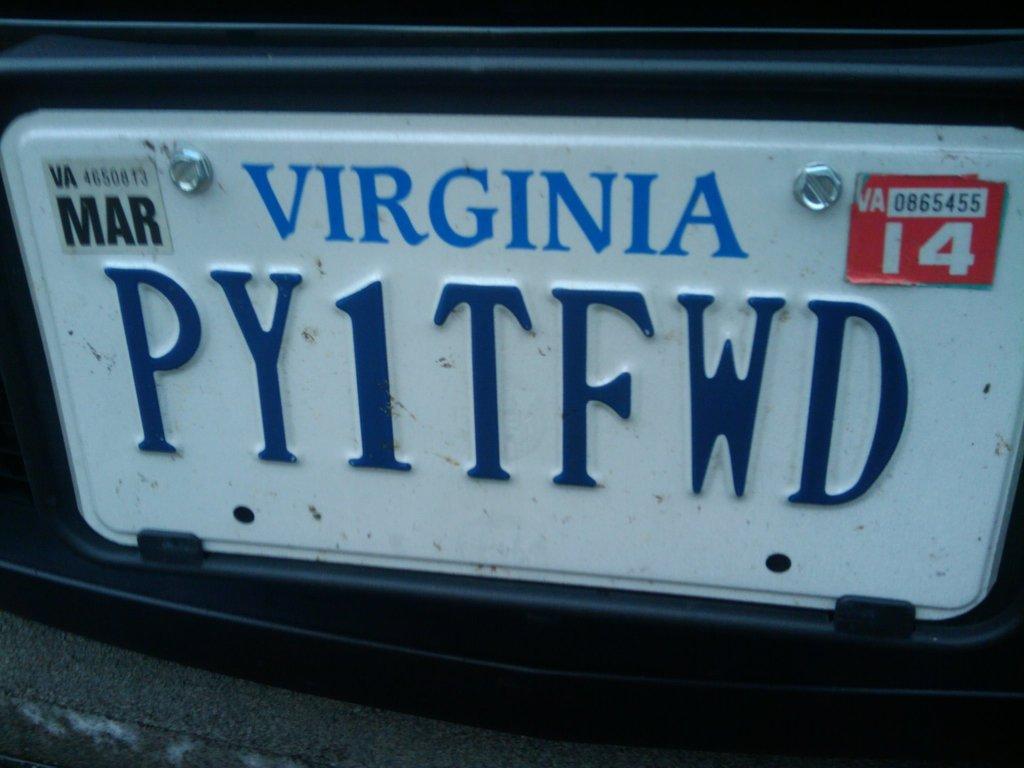Describe this image in one or two sentences. In this image I can see a number plate. The plate is white in color. The plate is attached to an object. On the plate I can see something written on it. 